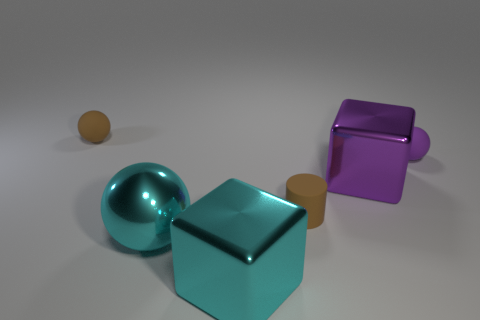Add 1 purple metal cubes. How many objects exist? 7 Subtract all cubes. How many objects are left? 4 Subtract 1 brown cylinders. How many objects are left? 5 Subtract all cyan metallic objects. Subtract all tiny purple matte things. How many objects are left? 3 Add 6 small cylinders. How many small cylinders are left? 7 Add 4 purple shiny cubes. How many purple shiny cubes exist? 5 